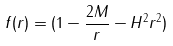<formula> <loc_0><loc_0><loc_500><loc_500>f ( r ) = ( 1 - \frac { 2 M } { r } - H ^ { 2 } r ^ { 2 } )</formula> 